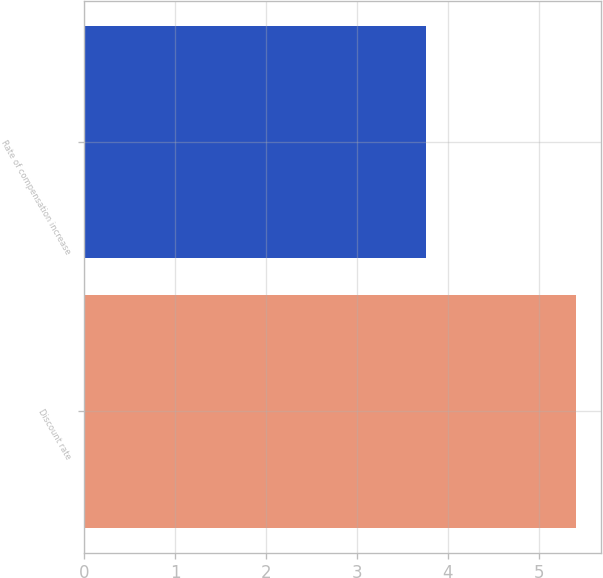<chart> <loc_0><loc_0><loc_500><loc_500><bar_chart><fcel>Discount rate<fcel>Rate of compensation increase<nl><fcel>5.41<fcel>3.76<nl></chart> 